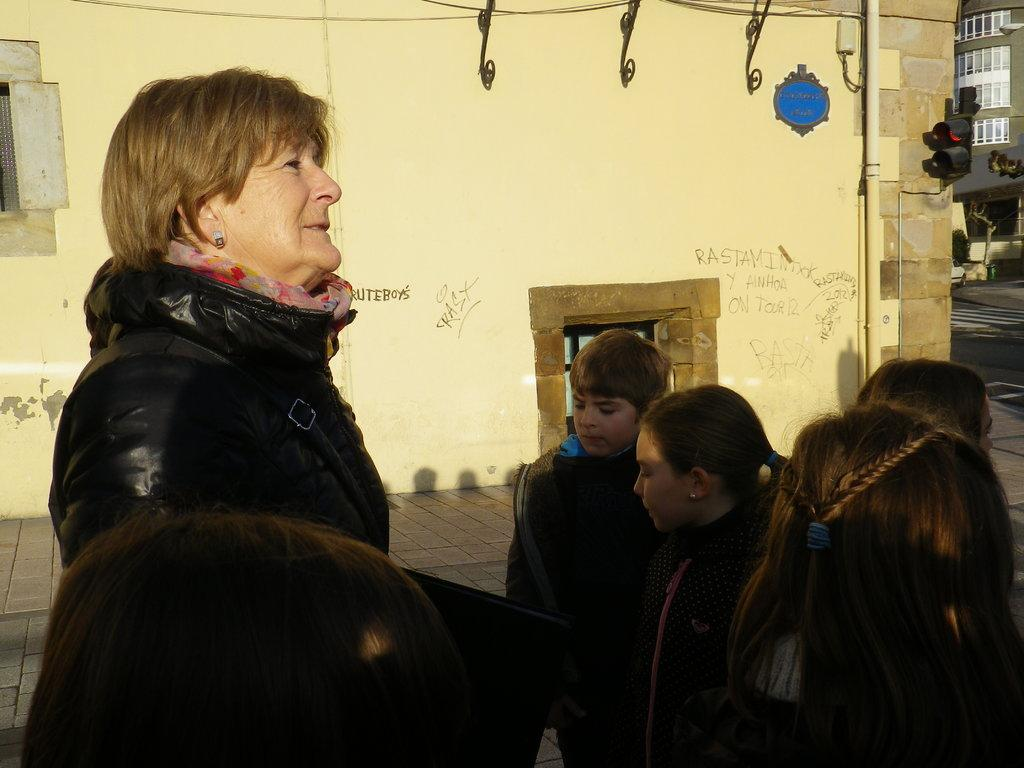What is the main subject of the image? There is a lady standing in the image. What is the lady wearing? The lady is wearing a jacket. Who else can be seen in the image besides the lady? There are kids in the image. What can be seen in the background of the image? There are buildings in the background of the image. What is located on the right side of the image? There are traffic lights on the right side of the image. Can you describe the waves crashing on the shore in the image? There are no waves or shore visible in the image; it features a lady, kids, buildings, and traffic lights. What type of growth is observed on the lady's jacket in the image? There is no growth visible on the lady's jacket in the image. 